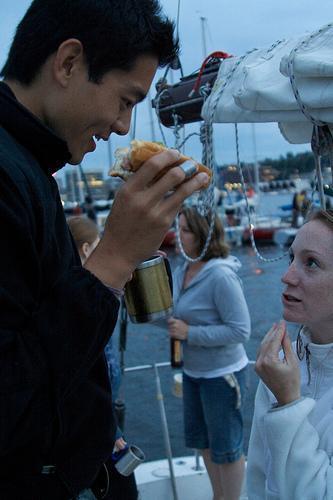How many men are in the picture?
Give a very brief answer. 1. 